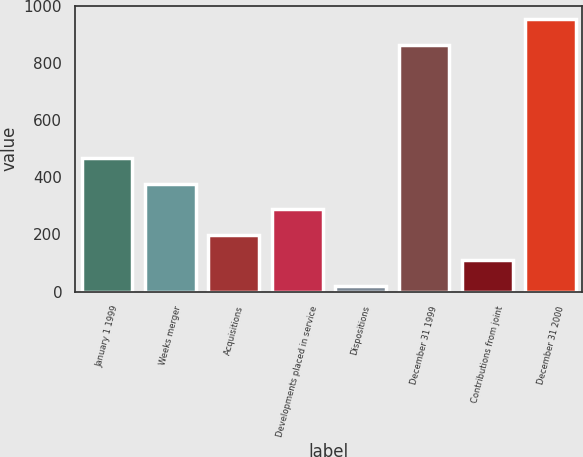Convert chart. <chart><loc_0><loc_0><loc_500><loc_500><bar_chart><fcel>January 1 1999<fcel>Weeks merger<fcel>Acquisitions<fcel>Developments placed in service<fcel>Dispositions<fcel>December 31 1999<fcel>Contributions from joint<fcel>December 31 2000<nl><fcel>467<fcel>377.8<fcel>199.4<fcel>288.6<fcel>21<fcel>865<fcel>110.2<fcel>954.2<nl></chart> 